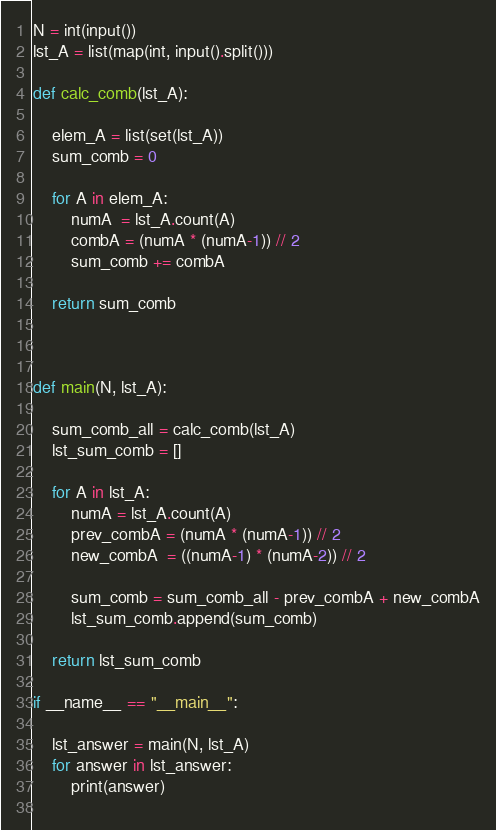<code> <loc_0><loc_0><loc_500><loc_500><_Python_>N = int(input())
lst_A = list(map(int, input().split()))

def calc_comb(lst_A):

    elem_A = list(set(lst_A))
    sum_comb = 0

    for A in elem_A:
        numA  = lst_A.count(A)
        combA = (numA * (numA-1)) // 2
        sum_comb += combA

    return sum_comb



def main(N, lst_A):

    sum_comb_all = calc_comb(lst_A)
    lst_sum_comb = []

    for A in lst_A:
        numA = lst_A.count(A)
        prev_combA = (numA * (numA-1)) // 2
        new_combA  = ((numA-1) * (numA-2)) // 2

        sum_comb = sum_comb_all - prev_combA + new_combA
        lst_sum_comb.append(sum_comb)

    return lst_sum_comb

if __name__ == "__main__":

    lst_answer = main(N, lst_A)
    for answer in lst_answer:
        print(answer)
    </code> 